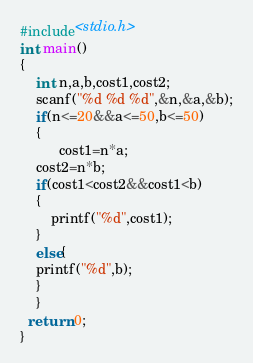<code> <loc_0><loc_0><loc_500><loc_500><_C_>#include<stdio.h>
int main()
{
    int n,a,b,cost1,cost2;
    scanf("%d %d %d",&n,&a,&b);
    if(n<=20&&a<=50,b<=50)
    {
          cost1=n*a;
    cost2=n*b;
    if(cost1<cost2&&cost1<b)
    {
        printf("%d",cost1);
    }
    else{
    printf("%d",b);
    }
    }
  return 0;
}
</code> 